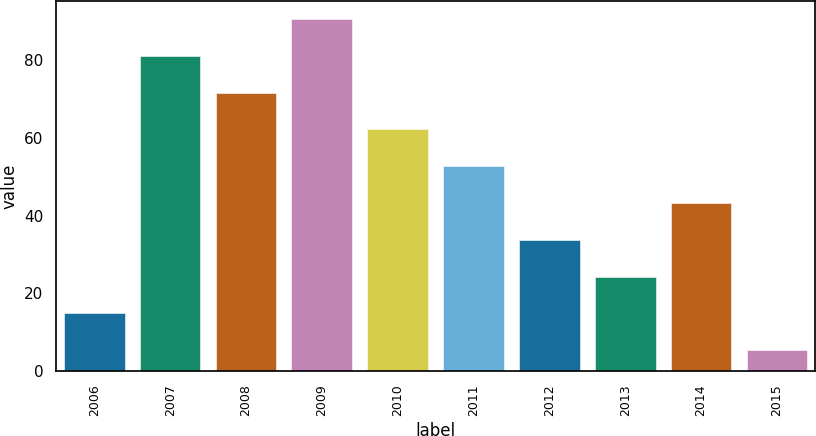Convert chart to OTSL. <chart><loc_0><loc_0><loc_500><loc_500><bar_chart><fcel>2006<fcel>2007<fcel>2008<fcel>2009<fcel>2010<fcel>2011<fcel>2012<fcel>2013<fcel>2014<fcel>2015<nl><fcel>14.86<fcel>81.08<fcel>71.62<fcel>90.54<fcel>62.16<fcel>52.7<fcel>33.78<fcel>24.32<fcel>43.24<fcel>5.4<nl></chart> 